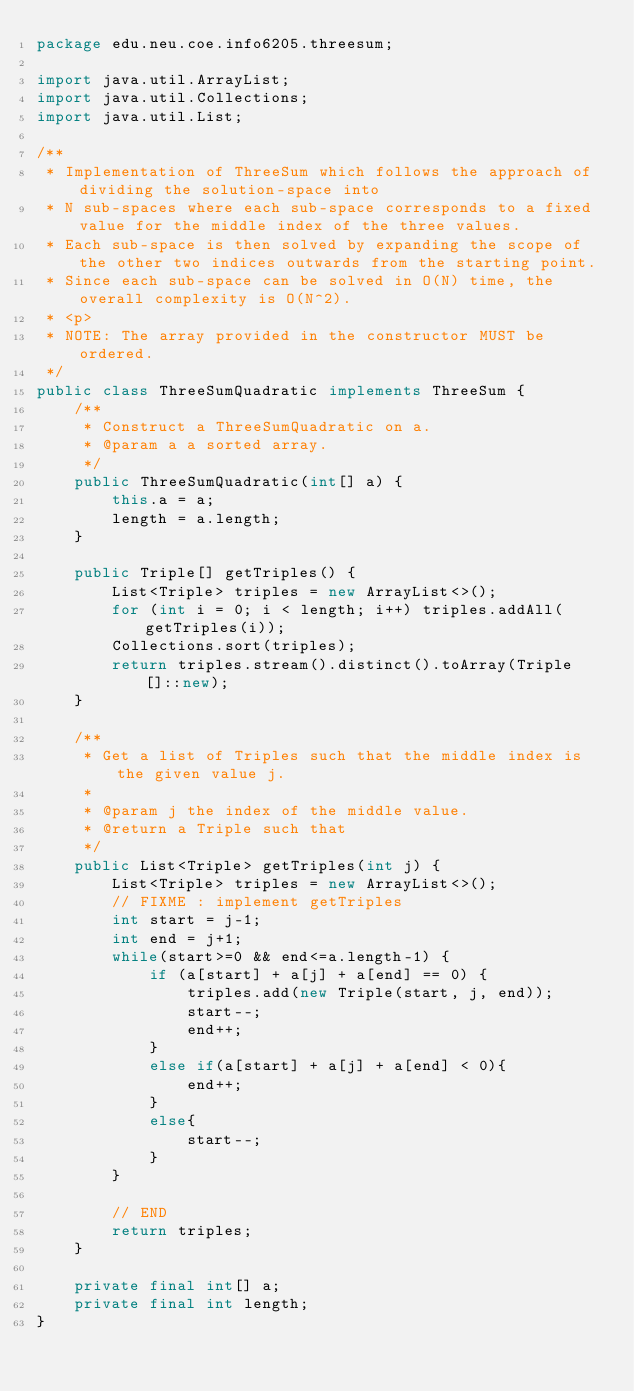Convert code to text. <code><loc_0><loc_0><loc_500><loc_500><_Java_>package edu.neu.coe.info6205.threesum;

import java.util.ArrayList;
import java.util.Collections;
import java.util.List;

/**
 * Implementation of ThreeSum which follows the approach of dividing the solution-space into
 * N sub-spaces where each sub-space corresponds to a fixed value for the middle index of the three values.
 * Each sub-space is then solved by expanding the scope of the other two indices outwards from the starting point.
 * Since each sub-space can be solved in O(N) time, the overall complexity is O(N^2).
 * <p>
 * NOTE: The array provided in the constructor MUST be ordered.
 */
public class ThreeSumQuadratic implements ThreeSum {
    /**
     * Construct a ThreeSumQuadratic on a.
     * @param a a sorted array.
     */
    public ThreeSumQuadratic(int[] a) {
        this.a = a;
        length = a.length;
    }

    public Triple[] getTriples() {
        List<Triple> triples = new ArrayList<>();
        for (int i = 0; i < length; i++) triples.addAll(getTriples(i));
        Collections.sort(triples);
        return triples.stream().distinct().toArray(Triple[]::new);
    }

    /**
     * Get a list of Triples such that the middle index is the given value j.
     *
     * @param j the index of the middle value.
     * @return a Triple such that
     */
    public List<Triple> getTriples(int j) {
        List<Triple> triples = new ArrayList<>();
        // FIXME : implement getTriples
        int start = j-1;
        int end = j+1;
        while(start>=0 && end<=a.length-1) {
            if (a[start] + a[j] + a[end] == 0) {
                triples.add(new Triple(start, j, end));
                start--;
                end++;
            }
            else if(a[start] + a[j] + a[end] < 0){
                end++;
            }
            else{
                start--;
            }
        }

        // END 
        return triples;
    }

    private final int[] a;
    private final int length;
}
</code> 